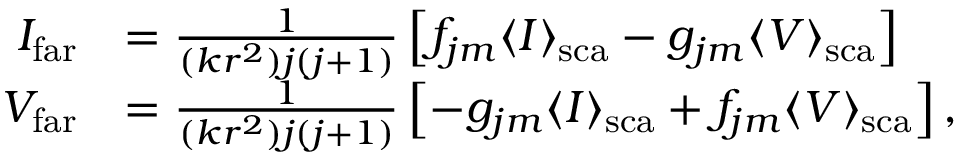Convert formula to latex. <formula><loc_0><loc_0><loc_500><loc_500>\begin{array} { r l } { I _ { f a r } } & { = \frac { 1 } { ( k r ^ { 2 } ) j ( j + 1 ) } \left [ f _ { j m } \langle I \rangle _ { s c a } - g _ { j m } \langle V \rangle _ { s c a } \right ] } \\ { V _ { f a r } } & { = \frac { 1 } { ( k r ^ { 2 } ) j ( j + 1 ) } \left [ - g _ { j m } \langle I \rangle _ { s c a } + f _ { j m } \langle V \rangle _ { s c a } \right ] , } \end{array}</formula> 